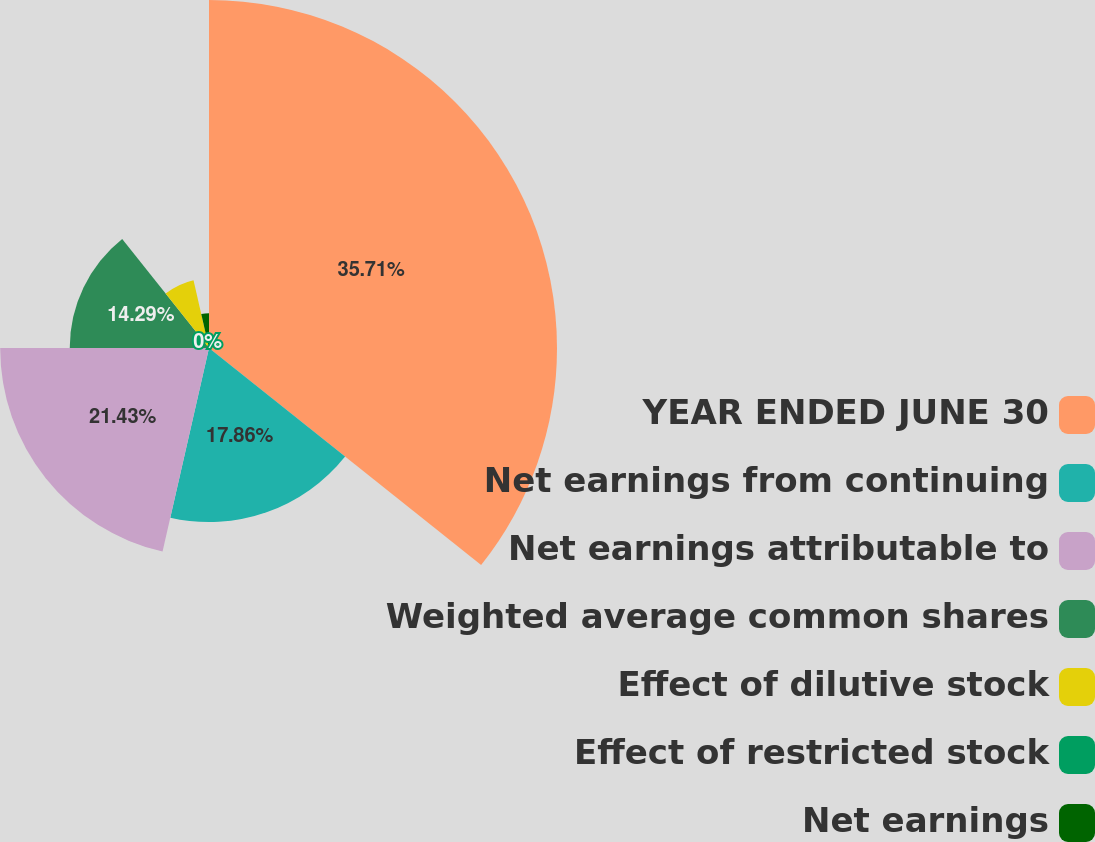Convert chart to OTSL. <chart><loc_0><loc_0><loc_500><loc_500><pie_chart><fcel>YEAR ENDED JUNE 30<fcel>Net earnings from continuing<fcel>Net earnings attributable to<fcel>Weighted average common shares<fcel>Effect of dilutive stock<fcel>Effect of restricted stock<fcel>Net earnings<nl><fcel>35.71%<fcel>17.86%<fcel>21.43%<fcel>14.29%<fcel>7.14%<fcel>0.0%<fcel>3.57%<nl></chart> 